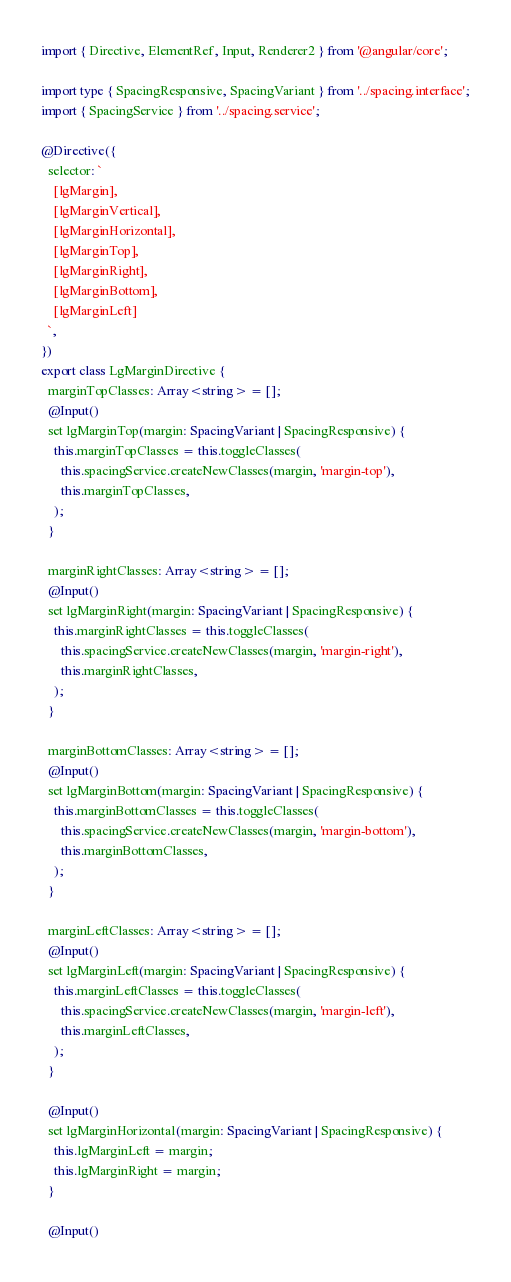Convert code to text. <code><loc_0><loc_0><loc_500><loc_500><_TypeScript_>import { Directive, ElementRef, Input, Renderer2 } from '@angular/core';

import type { SpacingResponsive, SpacingVariant } from '../spacing.interface';
import { SpacingService } from '../spacing.service';

@Directive({
  selector: `
    [lgMargin],
    [lgMarginVertical],
    [lgMarginHorizontal],
    [lgMarginTop],
    [lgMarginRight],
    [lgMarginBottom],
    [lgMarginLeft]
  `,
})
export class LgMarginDirective {
  marginTopClasses: Array<string> = [];
  @Input()
  set lgMarginTop(margin: SpacingVariant | SpacingResponsive) {
    this.marginTopClasses = this.toggleClasses(
      this.spacingService.createNewClasses(margin, 'margin-top'),
      this.marginTopClasses,
    );
  }

  marginRightClasses: Array<string> = [];
  @Input()
  set lgMarginRight(margin: SpacingVariant | SpacingResponsive) {
    this.marginRightClasses = this.toggleClasses(
      this.spacingService.createNewClasses(margin, 'margin-right'),
      this.marginRightClasses,
    );
  }

  marginBottomClasses: Array<string> = [];
  @Input()
  set lgMarginBottom(margin: SpacingVariant | SpacingResponsive) {
    this.marginBottomClasses = this.toggleClasses(
      this.spacingService.createNewClasses(margin, 'margin-bottom'),
      this.marginBottomClasses,
    );
  }

  marginLeftClasses: Array<string> = [];
  @Input()
  set lgMarginLeft(margin: SpacingVariant | SpacingResponsive) {
    this.marginLeftClasses = this.toggleClasses(
      this.spacingService.createNewClasses(margin, 'margin-left'),
      this.marginLeftClasses,
    );
  }

  @Input()
  set lgMarginHorizontal(margin: SpacingVariant | SpacingResponsive) {
    this.lgMarginLeft = margin;
    this.lgMarginRight = margin;
  }

  @Input()</code> 